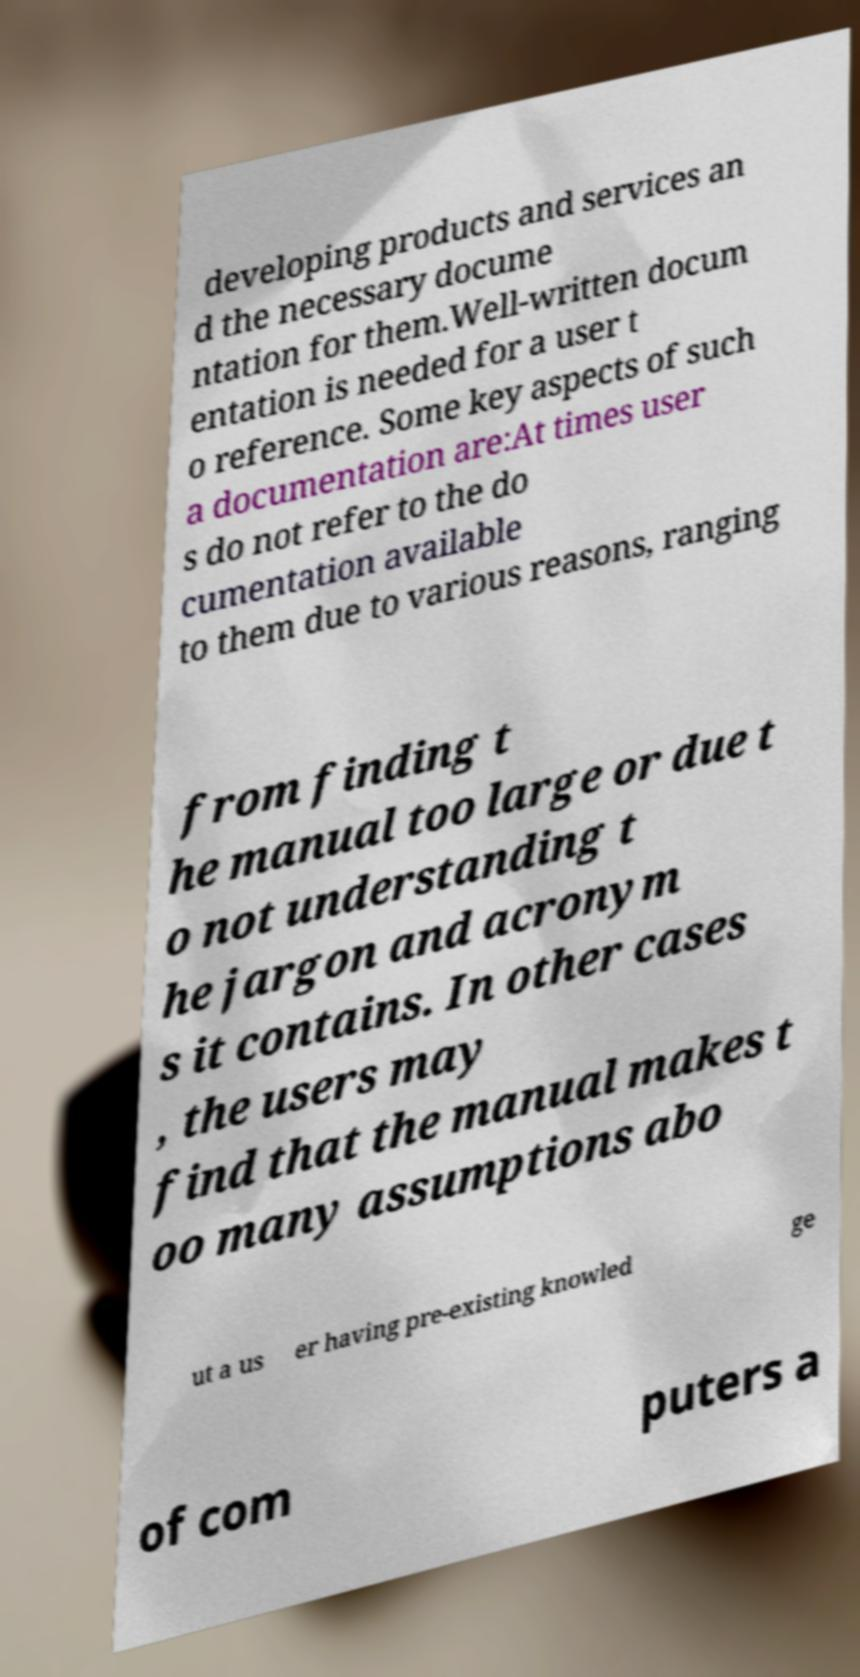For documentation purposes, I need the text within this image transcribed. Could you provide that? developing products and services an d the necessary docume ntation for them.Well-written docum entation is needed for a user t o reference. Some key aspects of such a documentation are:At times user s do not refer to the do cumentation available to them due to various reasons, ranging from finding t he manual too large or due t o not understanding t he jargon and acronym s it contains. In other cases , the users may find that the manual makes t oo many assumptions abo ut a us er having pre-existing knowled ge of com puters a 